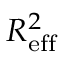<formula> <loc_0><loc_0><loc_500><loc_500>R _ { e f f } ^ { 2 }</formula> 